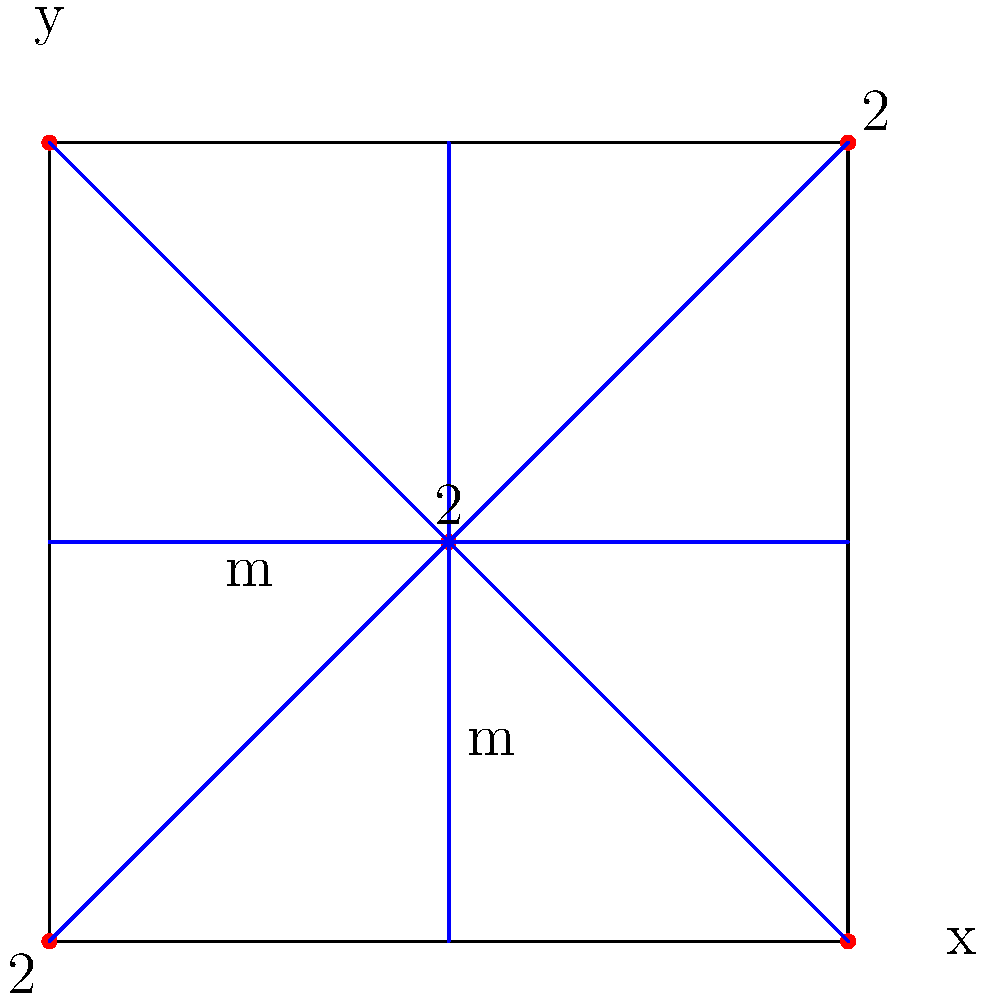In the context of wallpaper patterns, what is the Hermann–Mauguin notation for the symmetry group represented in this unit cell diagram? Explain how this notation relates to the symmetry elements shown and their arrangement within the unit cell. To determine the Hermann–Mauguin notation for this wallpaper pattern, we need to analyze the symmetry elements present in the unit cell:

1. Rotation centers:
   - 2-fold rotation centers at the corners and center of the unit cell

2. Mirror lines:
   - Horizontal and vertical mirror lines through the center of the unit cell
   - Diagonal mirror lines from corner to corner

Step-by-step analysis:

1. The highest-order rotation is 2-fold (180°), indicated by the "2" labels.
2. There are two sets of perpendicular mirror lines (horizontal and vertical).
3. There are also diagonal mirror lines.

The Hermann–Mauguin notation for wallpaper groups follows the format:
[Highest rotation order][Primary mirror direction][Secondary mirror direction]

In this case:
- Highest rotation order: 2
- Primary mirror direction: m (vertical or horizontal)
- Secondary mirror direction: m (the other direction)

The presence of diagonal mirror lines in addition to the perpendicular ones indicates that this is a special case where both primary and secondary directions have mirror symmetry.

Therefore, the Hermann–Mauguin notation for this wallpaper pattern is p2mm.

- p: indicates a primitive cell (default for wallpaper patterns)
- 2: highest rotation order
- mm: mirrors in both primary and secondary directions

This notation succinctly describes the symmetry group of the wallpaper pattern, including all the rotation centers and mirror lines visible in the unit cell diagram.
Answer: p2mm 